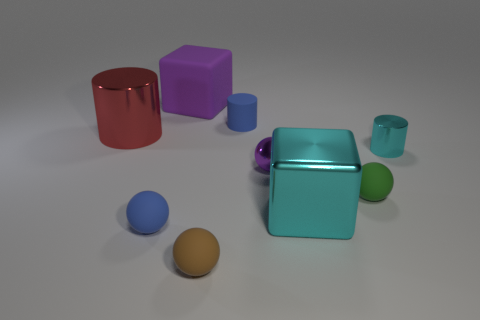How many metallic cylinders are there?
Your answer should be compact. 2. The cube that is behind the cyan metallic thing that is behind the cyan shiny block is made of what material?
Ensure brevity in your answer.  Rubber. The tiny cylinder that is on the right side of the big shiny object in front of the big cylinder in front of the large matte object is what color?
Make the answer very short. Cyan. Is the color of the big cylinder the same as the matte block?
Keep it short and to the point. No. How many metallic cylinders are the same size as the purple block?
Offer a terse response. 1. Is the number of cylinders left of the tiny green thing greater than the number of big objects behind the big purple rubber object?
Offer a very short reply. Yes. What is the color of the block on the left side of the small rubber thing that is behind the big cylinder?
Make the answer very short. Purple. Is the material of the large purple object the same as the big cyan block?
Keep it short and to the point. No. Is there a big purple matte object of the same shape as the large cyan thing?
Your response must be concise. Yes. There is a big thing that is in front of the purple shiny sphere; does it have the same color as the tiny shiny cylinder?
Ensure brevity in your answer.  Yes. 